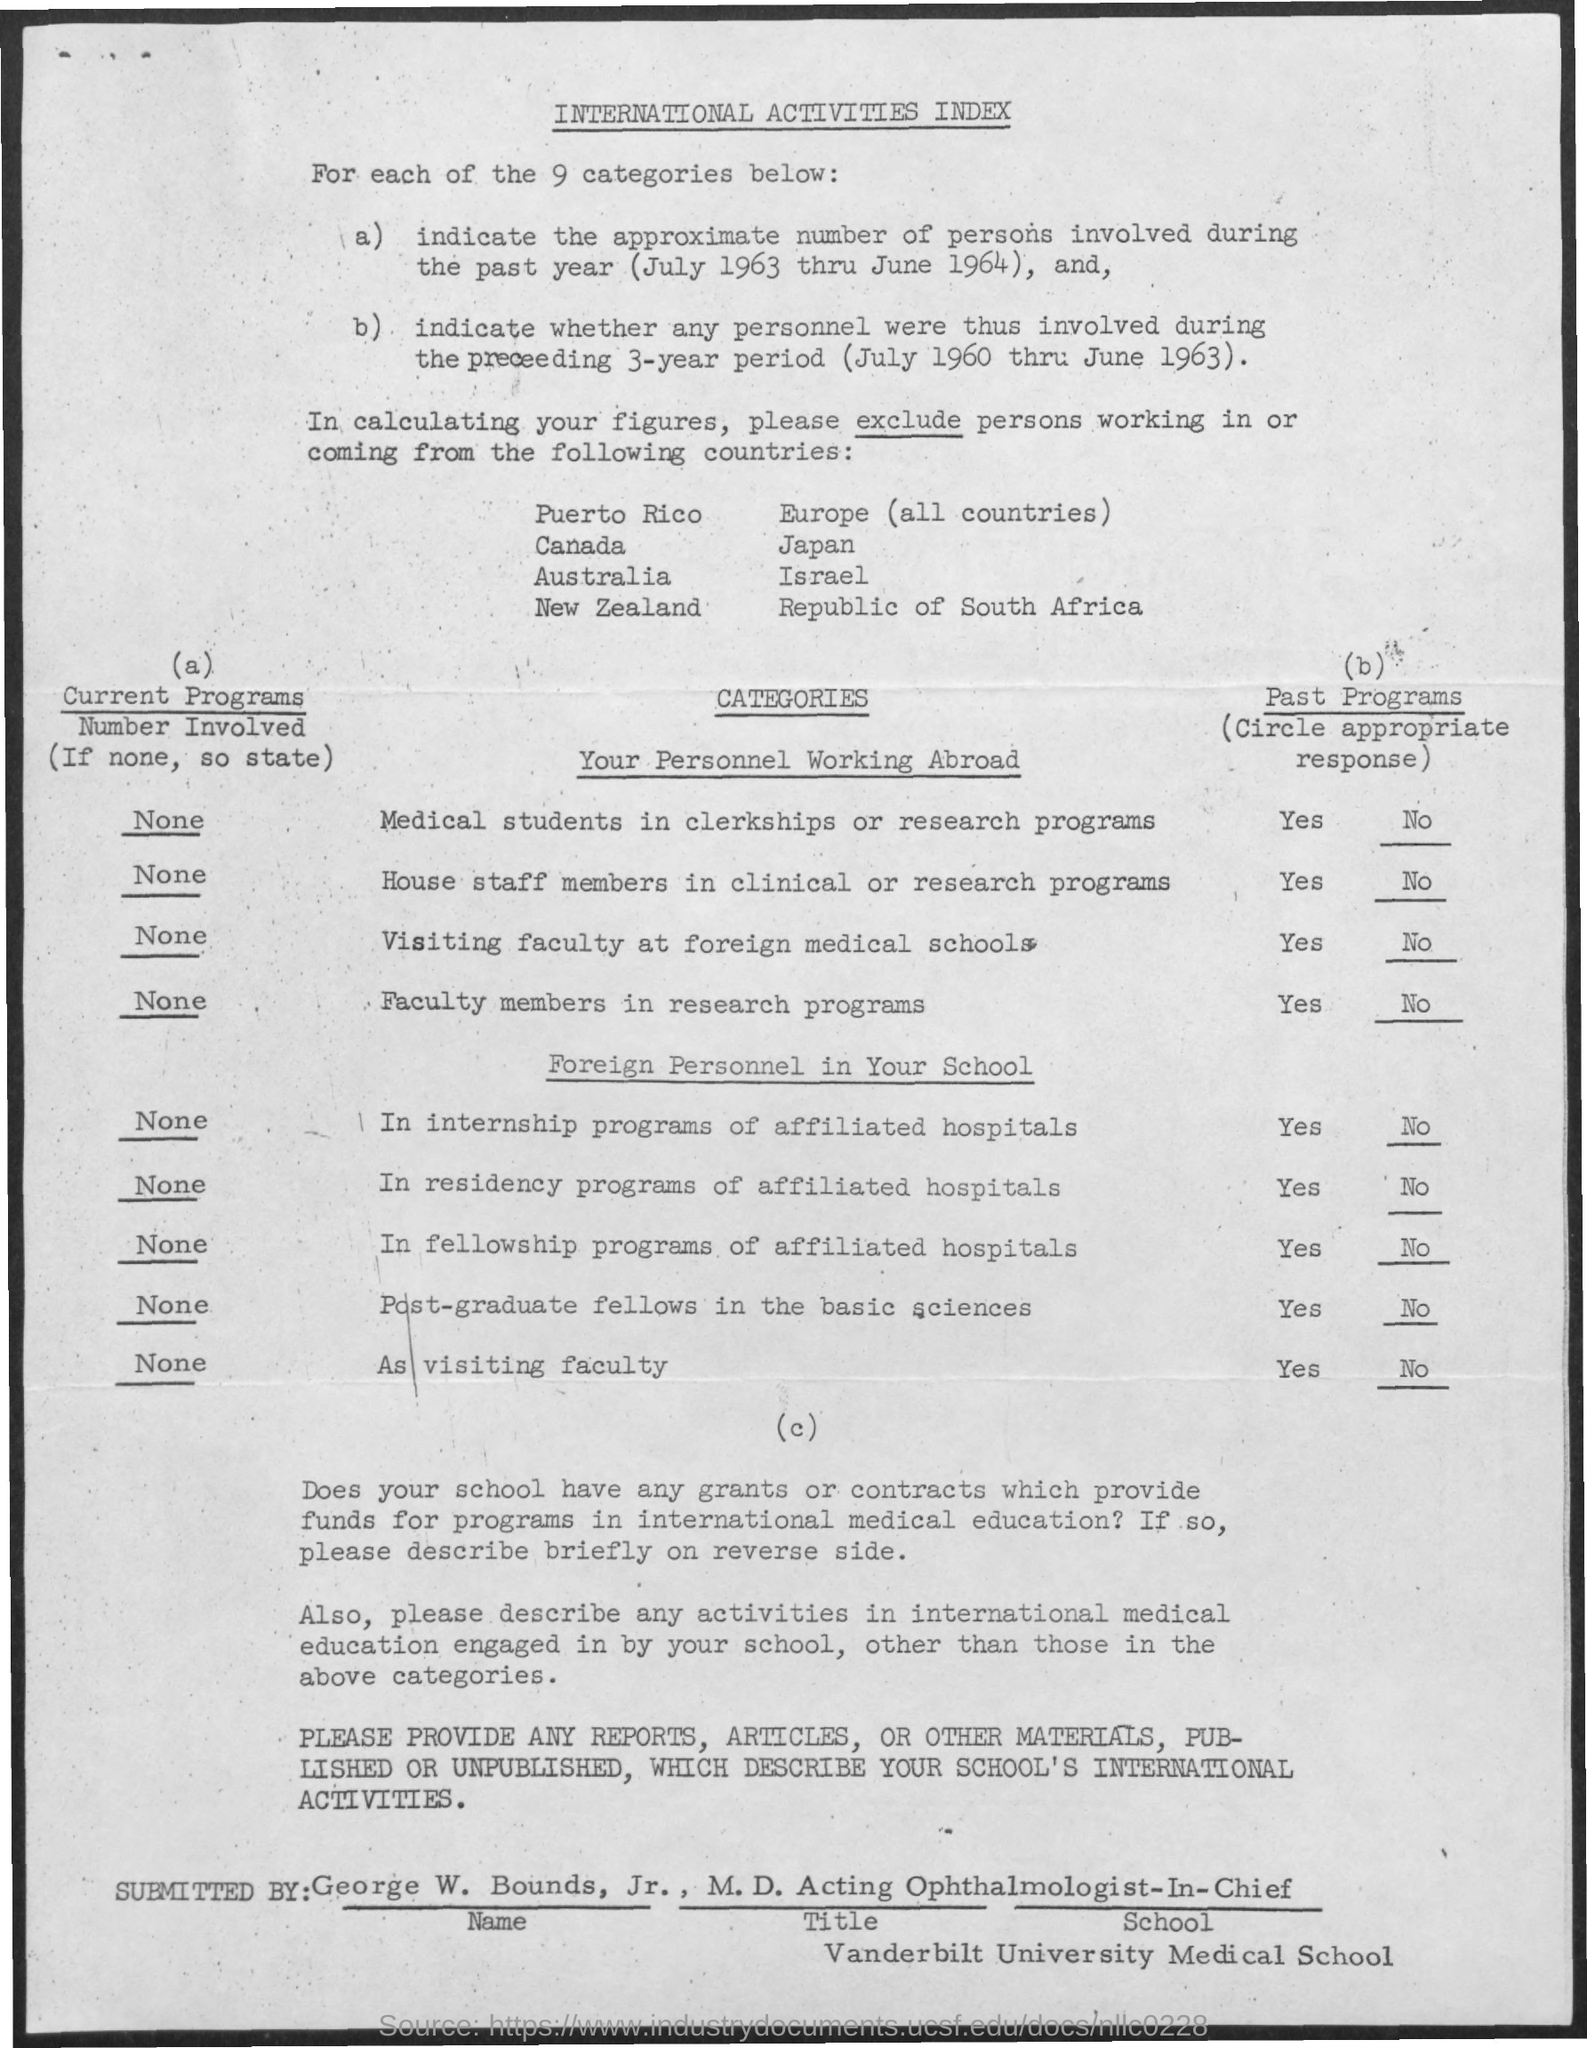Identify some key points in this picture. There are 9 categories in total. The title of the document is the International Activities Index. 